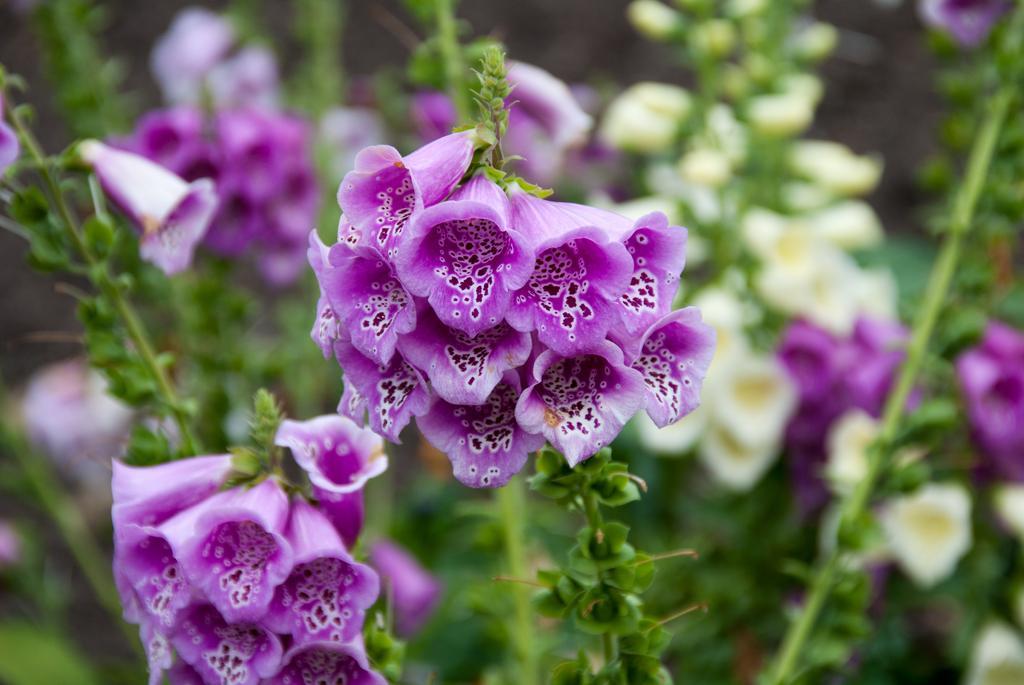Could you give a brief overview of what you see in this image? In this picture I can see there are few purple flowers, in the backdrop, there are few white flowers and there are few leaves. The backdrop is blurred. 